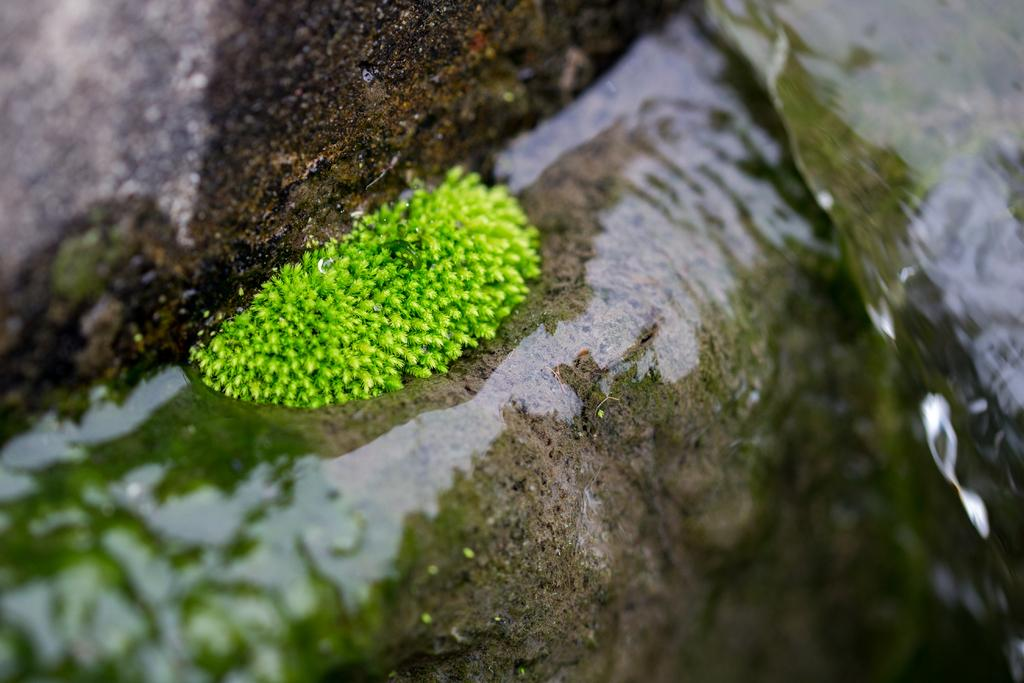What is the plant doing in the image? The plant is in the water in the image. What else can be seen in the background of the image? There are rocks visible in the background of the image. How much money is the plant holding in the image? There is no money present in the image; it features a plant in the water and rocks in the background. 